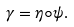<formula> <loc_0><loc_0><loc_500><loc_500>\gamma = \eta \circ \psi .</formula> 